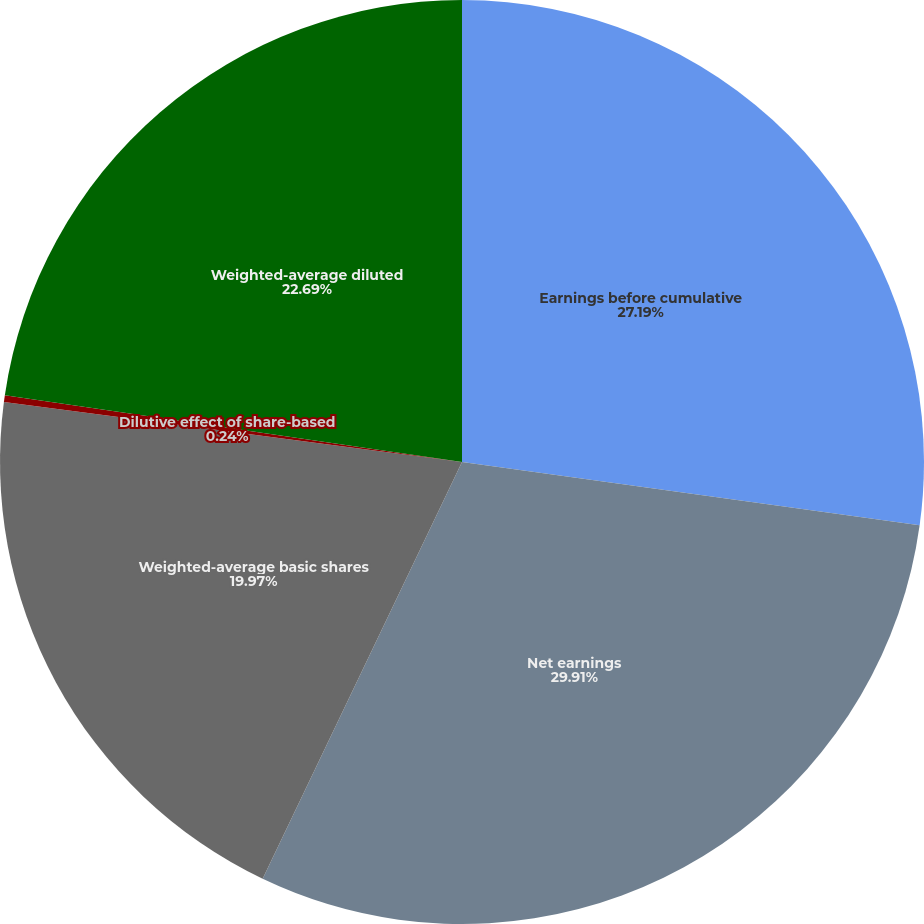Convert chart to OTSL. <chart><loc_0><loc_0><loc_500><loc_500><pie_chart><fcel>Earnings before cumulative<fcel>Net earnings<fcel>Weighted-average basic shares<fcel>Dilutive effect of share-based<fcel>Weighted-average diluted<nl><fcel>27.19%<fcel>29.91%<fcel>19.97%<fcel>0.24%<fcel>22.69%<nl></chart> 